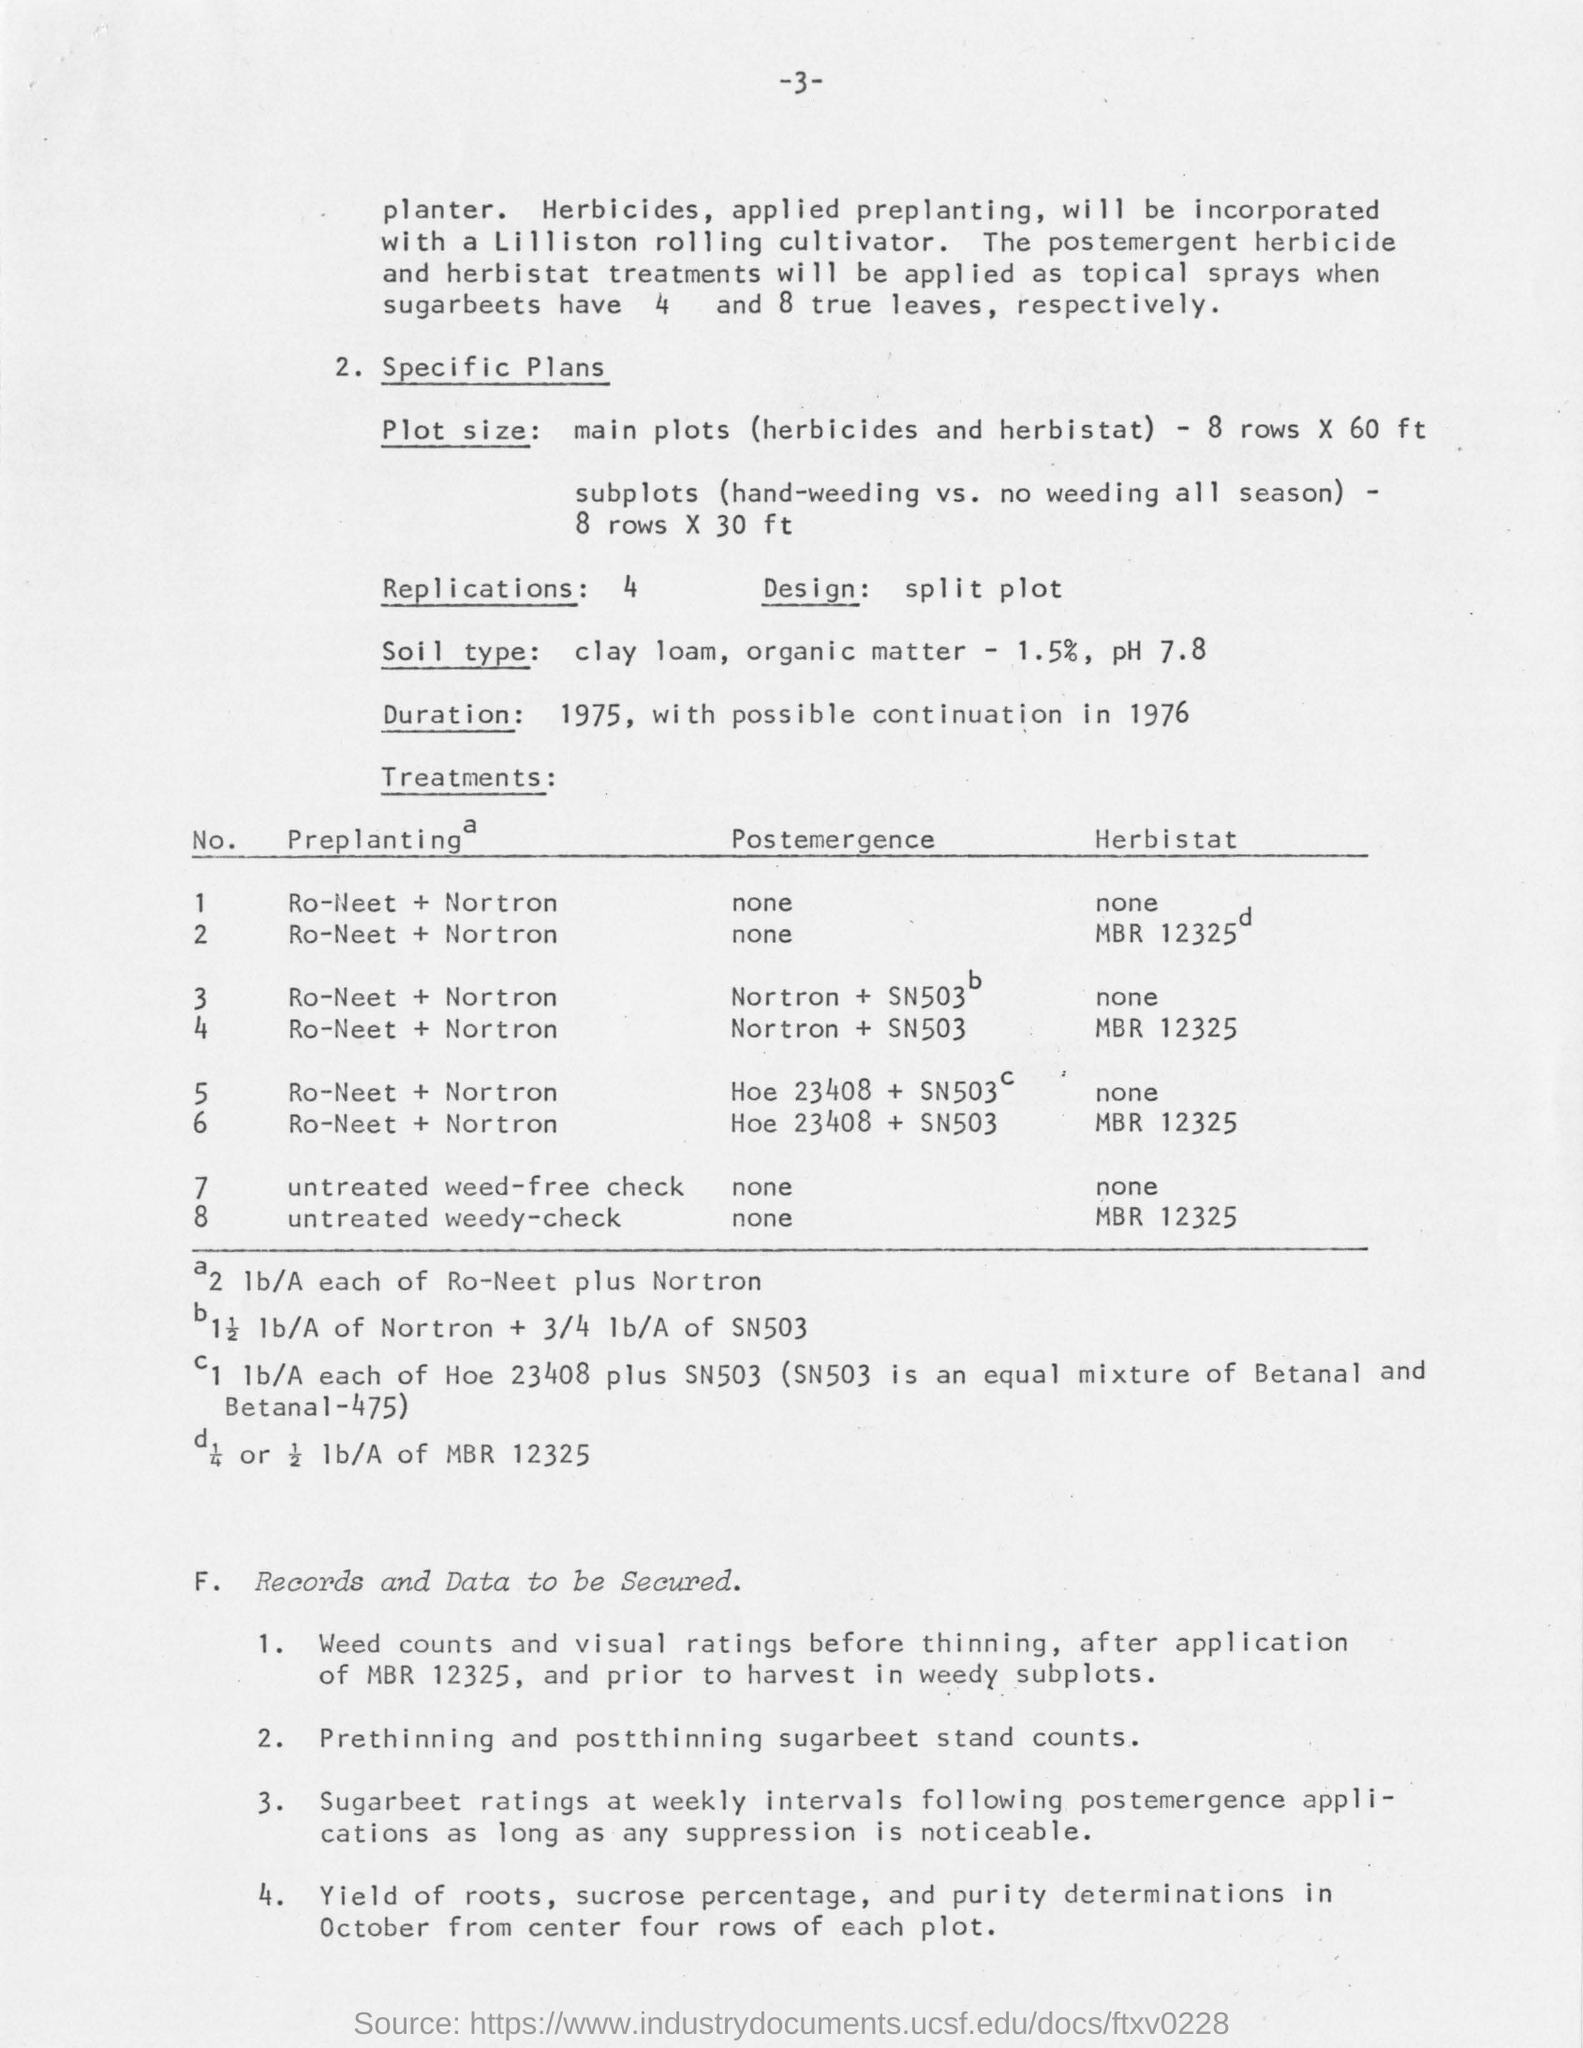Point out several critical features in this image. The pH value of clay loam soil is 7.8. The rate of organic matter present in clay loam soil is 1.5%. The treatments that will be applied as topical sprays to sugarbeets that have four and eight true leaves, respectively, are the postemergent herbicide and herbicstat treatments. The plot size for subplots comparing hand weeding versus no weeding all season, with 8 rows and a width of 30 feet. 